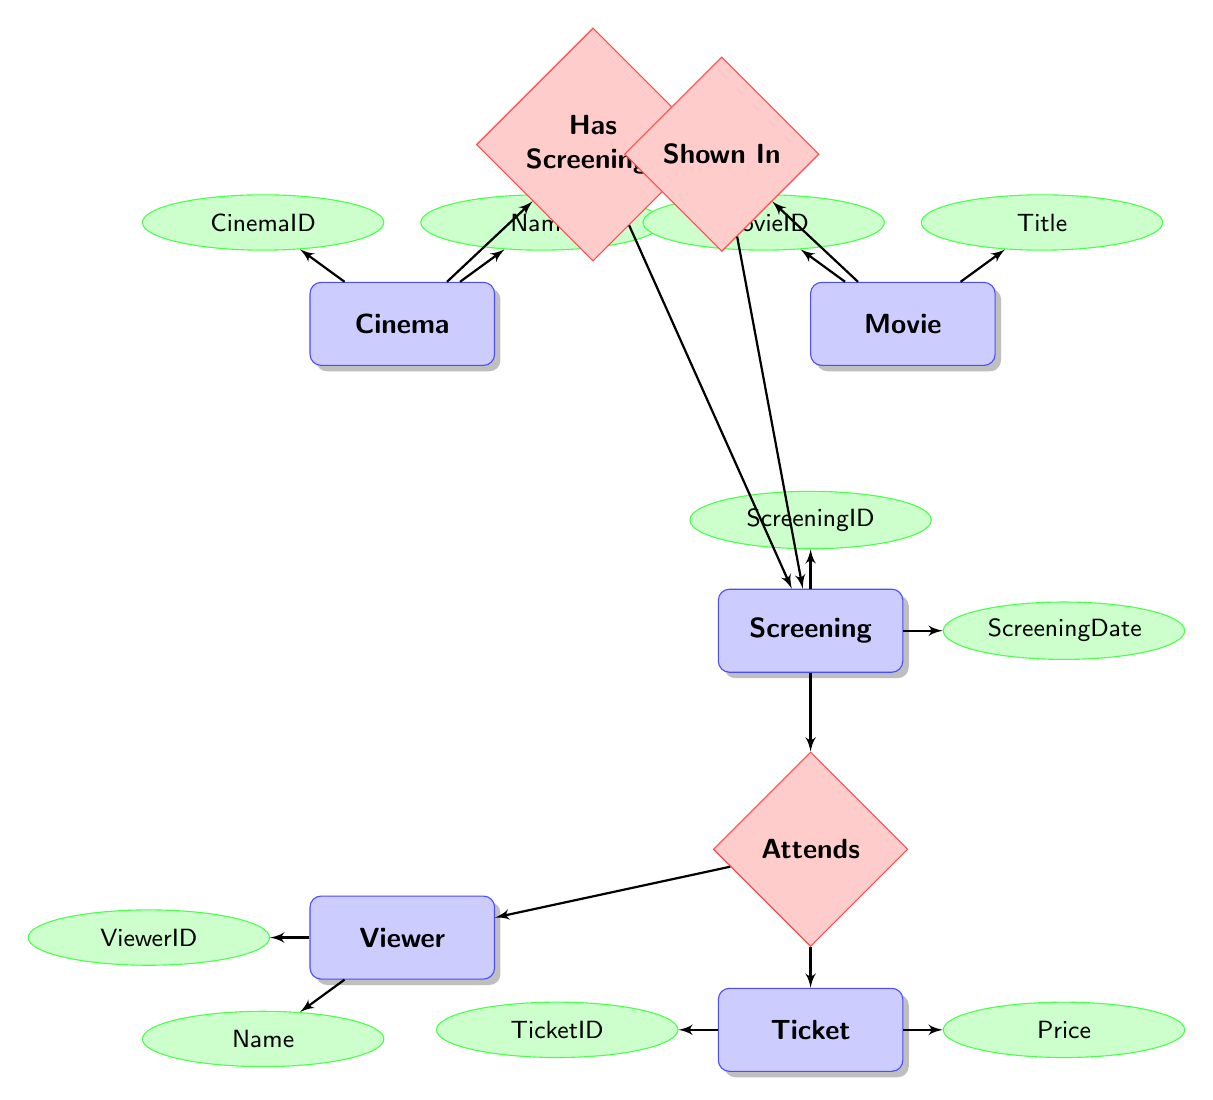What is the relationship between Cinema and Screening? The relationship between Cinema and Screening is described as "Has Screenings," indicating that one Cinema can have multiple Screenings associated with it.
Answer: Has Screenings How many attributes does the Viewer entity have? The Viewer entity has four attributes listed: ViewerID, Name, Email, and MembershipStatus. Therefore, the total count is four.
Answer: Four Which entity is connected to the Ticket entity through a ManyToMany relationship? The Ticket entity is connected to the Viewer entity through the "Attends" relationship, which defines a ManyToMany relationship.
Answer: Viewer What is the minimum height of the Movie entity? The minimum height of the Movie entity is specified as three em, which is a unit of measurement used in typography and design.
Answer: Three em What does the Screening entity relate to in terms of Movie? The Screening entity has a "Shown In" relationship with the Movie entity, indicating that a Screening is linked to a specific Movie.
Answer: Shown In How many total nodes are there in the diagram? The diagram has five main entities: Cinema, Movie, Screening, Viewer, and Ticket, leading to a total of five nodes.
Answer: Five Which entity has the attribute Name? Both the Cinema and Viewer entities have an attribute named Name, as indicated in their respective attribute lists.
Answer: Cinema, Viewer What is the maximum number of Screenings one Cinema can have? There is no explicit limit mentioned in the diagram for the number of Screenings a Cinema can have based on the "Has Screenings" relationship, indicating it can be many.
Answer: Many In the context of the diagram, what represents the link between Viewer and Screening? The link between Viewer and Screening is represented by the "Attends" relationship, which also involves the Ticket entity as a linking element due to its ManyToMany nature.
Answer: Attends 